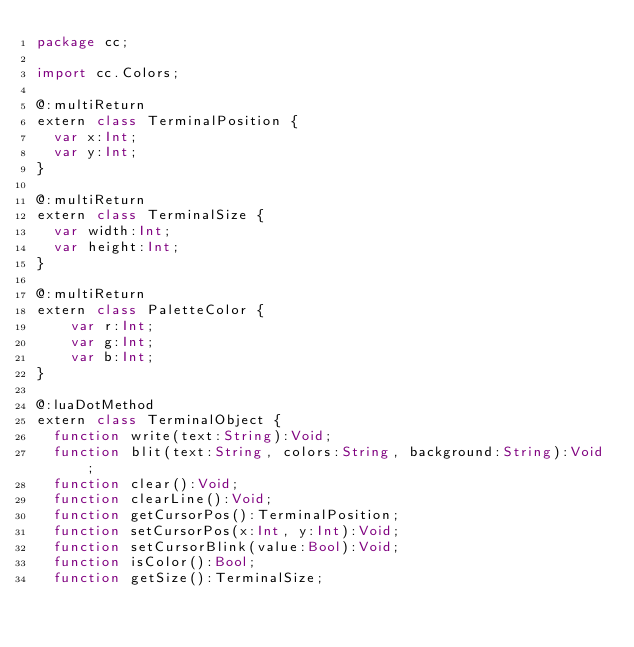<code> <loc_0><loc_0><loc_500><loc_500><_Haxe_>package cc;

import cc.Colors;

@:multiReturn
extern class TerminalPosition {
	var x:Int;
	var y:Int;
}

@:multiReturn
extern class TerminalSize {
	var width:Int;
	var height:Int;
}

@:multiReturn
extern class PaletteColor {
    var r:Int;
    var g:Int;
    var b:Int;
}

@:luaDotMethod
extern class TerminalObject {
	function write(text:String):Void;
	function blit(text:String, colors:String, background:String):Void;
	function clear():Void;
	function clearLine():Void;
	function getCursorPos():TerminalPosition;
	function setCursorPos(x:Int, y:Int):Void;
	function setCursorBlink(value:Bool):Void;
	function isColor():Bool;
	function getSize():TerminalSize;</code> 